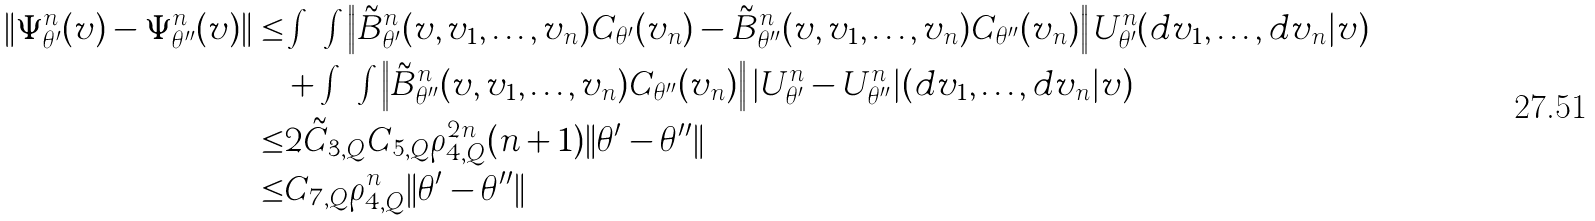<formula> <loc_0><loc_0><loc_500><loc_500>\| \Psi _ { \theta ^ { \prime } } ^ { n } ( v ) - \Psi _ { \theta ^ { \prime \prime } } ^ { n } ( v ) \| \leq & \int \cdots \int \left \| \tilde { B } _ { \theta ^ { \prime } } ^ { n } ( v , v _ { 1 } , \dots , v _ { n } ) C _ { \theta ^ { \prime } } ( v _ { n } ) - \tilde { B } _ { \theta ^ { \prime \prime } } ^ { n } ( v , v _ { 1 } , \dots , v _ { n } ) C _ { \theta ^ { \prime \prime } } ( v _ { n } ) \right \| U _ { \theta ^ { \prime } } ^ { n } ( d v _ { 1 } , \dots , d v _ { n } | v ) \\ & + \int \cdots \int \left \| \tilde { B } _ { \theta ^ { \prime \prime } } ^ { n } ( v , v _ { 1 } , \dots , v _ { n } ) C _ { \theta ^ { \prime \prime } } ( v _ { n } ) \right \| | U _ { \theta ^ { \prime } } ^ { n } - U _ { \theta ^ { \prime \prime } } ^ { n } | ( d v _ { 1 } , \dots , d v _ { n } | v ) \\ \leq & 2 \tilde { C } _ { 3 , Q } C _ { 5 , Q } \rho _ { 4 , Q } ^ { 2 n } ( n + 1 ) \| \theta ^ { \prime } - \theta ^ { \prime \prime } \| \\ \leq & C _ { 7 , Q } \rho _ { 4 , Q } ^ { n } \| \theta ^ { \prime } - \theta ^ { \prime \prime } \|</formula> 